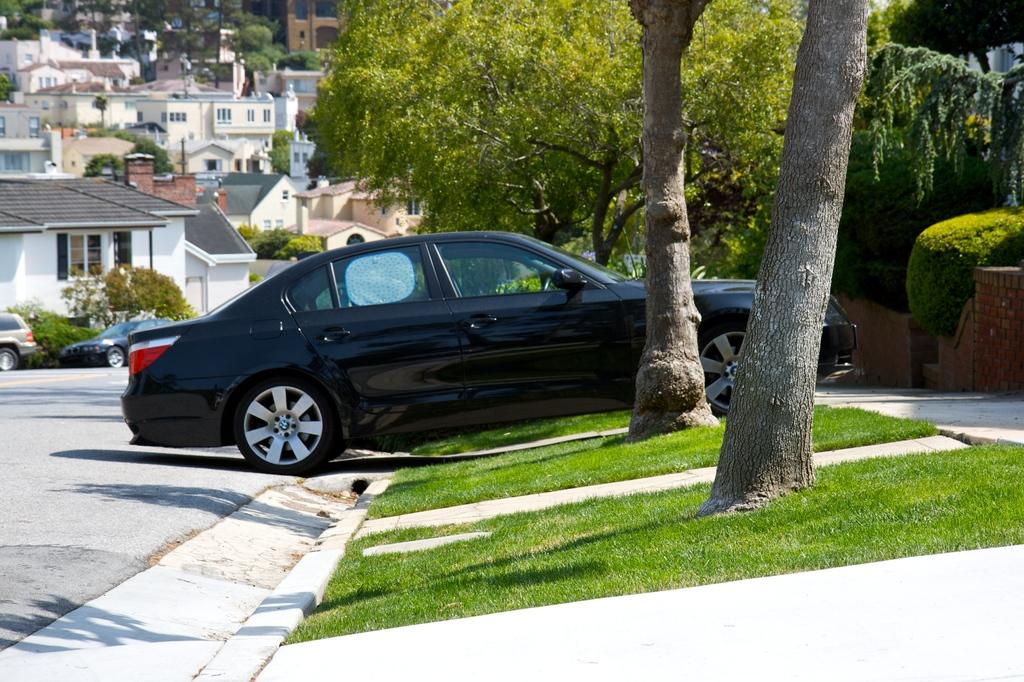What can be seen on the road in the image? There are vehicles on the road in the image. What type of vegetation is visible to the right of the image? There are trees and plants to the right of the image. What is visible in the background of the image? There are many buildings and additional trees in the background of the image. Can you see any celery growing in the image? There is no celery present in the image. Are there any fairies flying around the trees in the image? There are no fairies present in the image. 